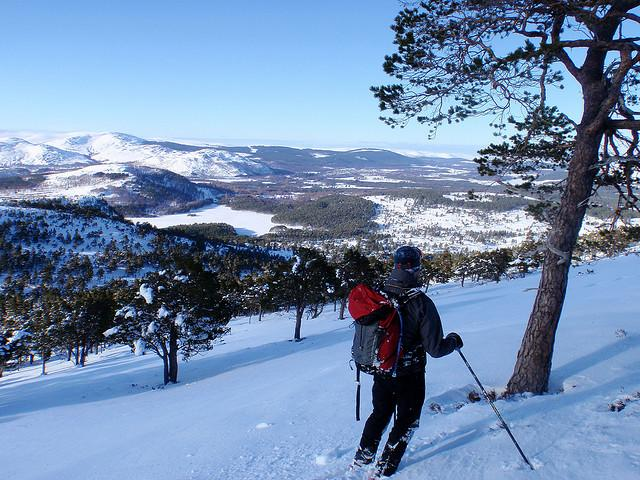What is the man doing in the snow?

Choices:
A) hiking
B) plowing
C) building snowmen
D) shoveling hiking 